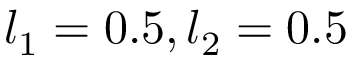Convert formula to latex. <formula><loc_0><loc_0><loc_500><loc_500>l _ { 1 } = 0 . 5 , l _ { 2 } = 0 . 5</formula> 